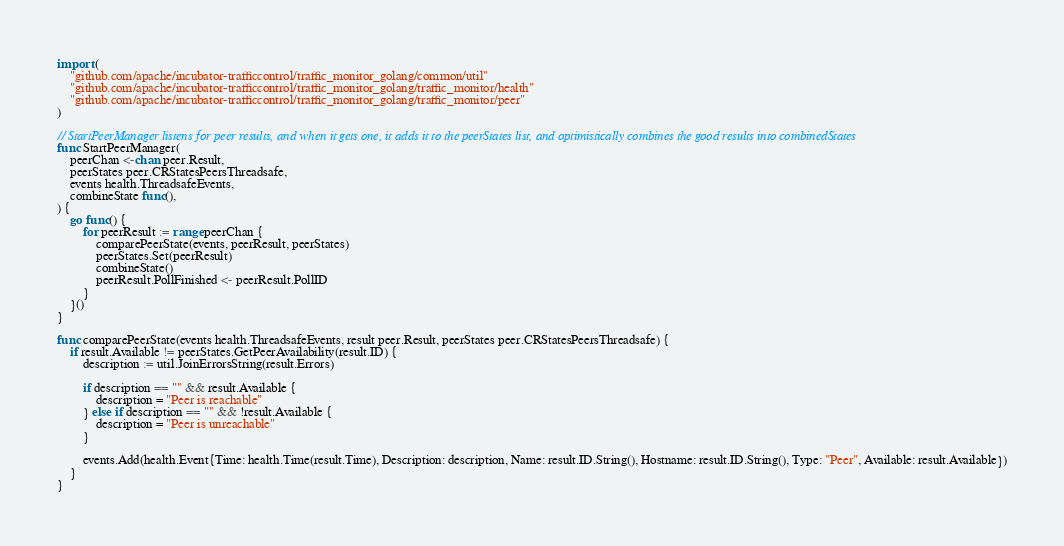Convert code to text. <code><loc_0><loc_0><loc_500><loc_500><_Go_>import (
	"github.com/apache/incubator-trafficcontrol/traffic_monitor_golang/common/util"
	"github.com/apache/incubator-trafficcontrol/traffic_monitor_golang/traffic_monitor/health"
	"github.com/apache/incubator-trafficcontrol/traffic_monitor_golang/traffic_monitor/peer"
)

// StartPeerManager listens for peer results, and when it gets one, it adds it to the peerStates list, and optimistically combines the good results into combinedStates
func StartPeerManager(
	peerChan <-chan peer.Result,
	peerStates peer.CRStatesPeersThreadsafe,
	events health.ThreadsafeEvents,
	combineState func(),
) {
	go func() {
		for peerResult := range peerChan {
			comparePeerState(events, peerResult, peerStates)
			peerStates.Set(peerResult)
			combineState()
			peerResult.PollFinished <- peerResult.PollID
		}
	}()
}

func comparePeerState(events health.ThreadsafeEvents, result peer.Result, peerStates peer.CRStatesPeersThreadsafe) {
	if result.Available != peerStates.GetPeerAvailability(result.ID) {
		description := util.JoinErrorsString(result.Errors)

		if description == "" && result.Available {
			description = "Peer is reachable"
		} else if description == "" && !result.Available {
			description = "Peer is unreachable"
		}

		events.Add(health.Event{Time: health.Time(result.Time), Description: description, Name: result.ID.String(), Hostname: result.ID.String(), Type: "Peer", Available: result.Available})
	}
}
</code> 